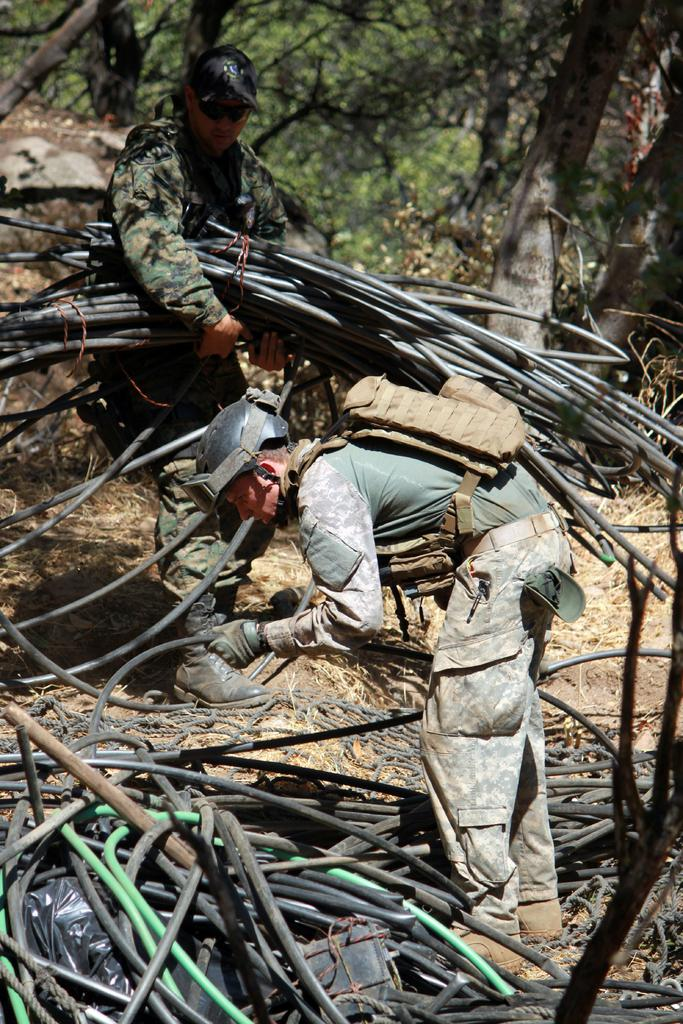How many people are in the image? There are two people in the image. What are the people holding in the image? The people are holding pipes in the image. What else can be seen in the image besides the people and pipes? There are ropes visible in the image, as well as a wooden object and grass. What is visible in the background of the image? There are trees in the background of the image. What type of bubble can be seen floating in the image? There is no bubble present in the image. What is the profit margin of the wooden object in the image? There is no information about the profit margin of the wooden object in the image, as it is not a business transaction. 